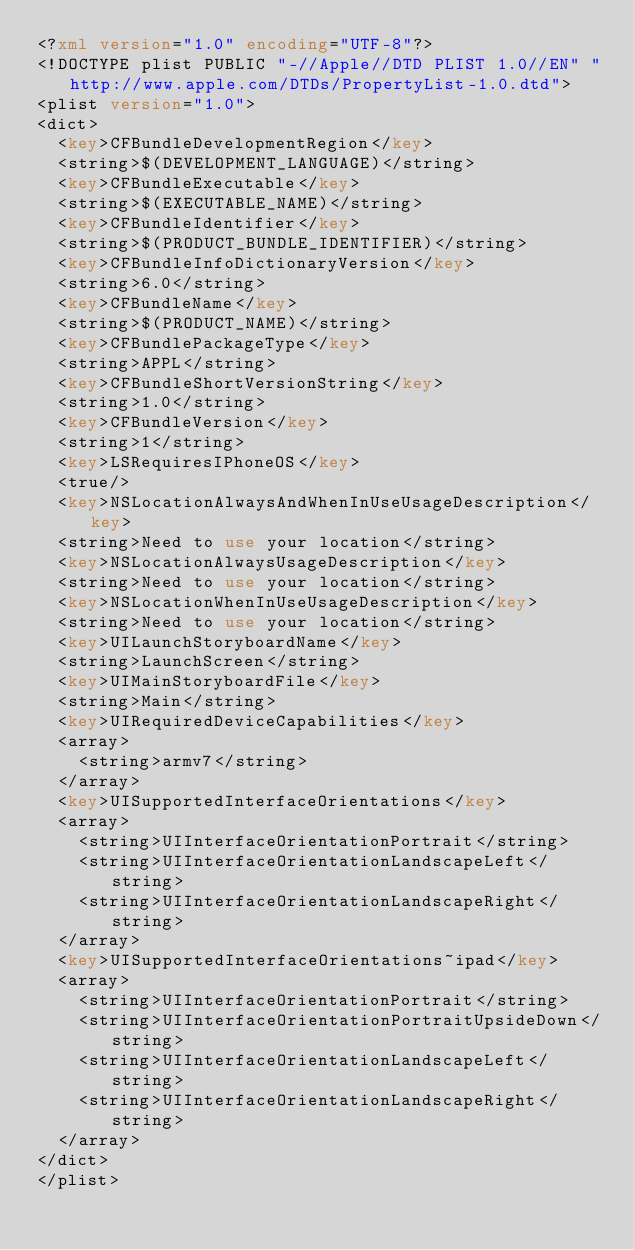<code> <loc_0><loc_0><loc_500><loc_500><_XML_><?xml version="1.0" encoding="UTF-8"?>
<!DOCTYPE plist PUBLIC "-//Apple//DTD PLIST 1.0//EN" "http://www.apple.com/DTDs/PropertyList-1.0.dtd">
<plist version="1.0">
<dict>
	<key>CFBundleDevelopmentRegion</key>
	<string>$(DEVELOPMENT_LANGUAGE)</string>
	<key>CFBundleExecutable</key>
	<string>$(EXECUTABLE_NAME)</string>
	<key>CFBundleIdentifier</key>
	<string>$(PRODUCT_BUNDLE_IDENTIFIER)</string>
	<key>CFBundleInfoDictionaryVersion</key>
	<string>6.0</string>
	<key>CFBundleName</key>
	<string>$(PRODUCT_NAME)</string>
	<key>CFBundlePackageType</key>
	<string>APPL</string>
	<key>CFBundleShortVersionString</key>
	<string>1.0</string>
	<key>CFBundleVersion</key>
	<string>1</string>
	<key>LSRequiresIPhoneOS</key>
	<true/>
	<key>NSLocationAlwaysAndWhenInUseUsageDescription</key>
	<string>Need to use your location</string>
	<key>NSLocationAlwaysUsageDescription</key>
	<string>Need to use your location</string>
	<key>NSLocationWhenInUseUsageDescription</key>
	<string>Need to use your location</string>
	<key>UILaunchStoryboardName</key>
	<string>LaunchScreen</string>
	<key>UIMainStoryboardFile</key>
	<string>Main</string>
	<key>UIRequiredDeviceCapabilities</key>
	<array>
		<string>armv7</string>
	</array>
	<key>UISupportedInterfaceOrientations</key>
	<array>
		<string>UIInterfaceOrientationPortrait</string>
		<string>UIInterfaceOrientationLandscapeLeft</string>
		<string>UIInterfaceOrientationLandscapeRight</string>
	</array>
	<key>UISupportedInterfaceOrientations~ipad</key>
	<array>
		<string>UIInterfaceOrientationPortrait</string>
		<string>UIInterfaceOrientationPortraitUpsideDown</string>
		<string>UIInterfaceOrientationLandscapeLeft</string>
		<string>UIInterfaceOrientationLandscapeRight</string>
	</array>
</dict>
</plist>
</code> 